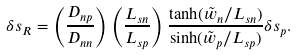Convert formula to latex. <formula><loc_0><loc_0><loc_500><loc_500>\delta s _ { R } = \left ( \frac { D _ { n p } } { D _ { n n } } \right ) \left ( \frac { L _ { s n } } { L _ { s p } } \right ) \frac { \tanh ( \tilde { w } _ { n } / L _ { s n } ) } { \sinh ( \tilde { w } _ { p } / L _ { s p } ) } \delta s _ { p } .</formula> 